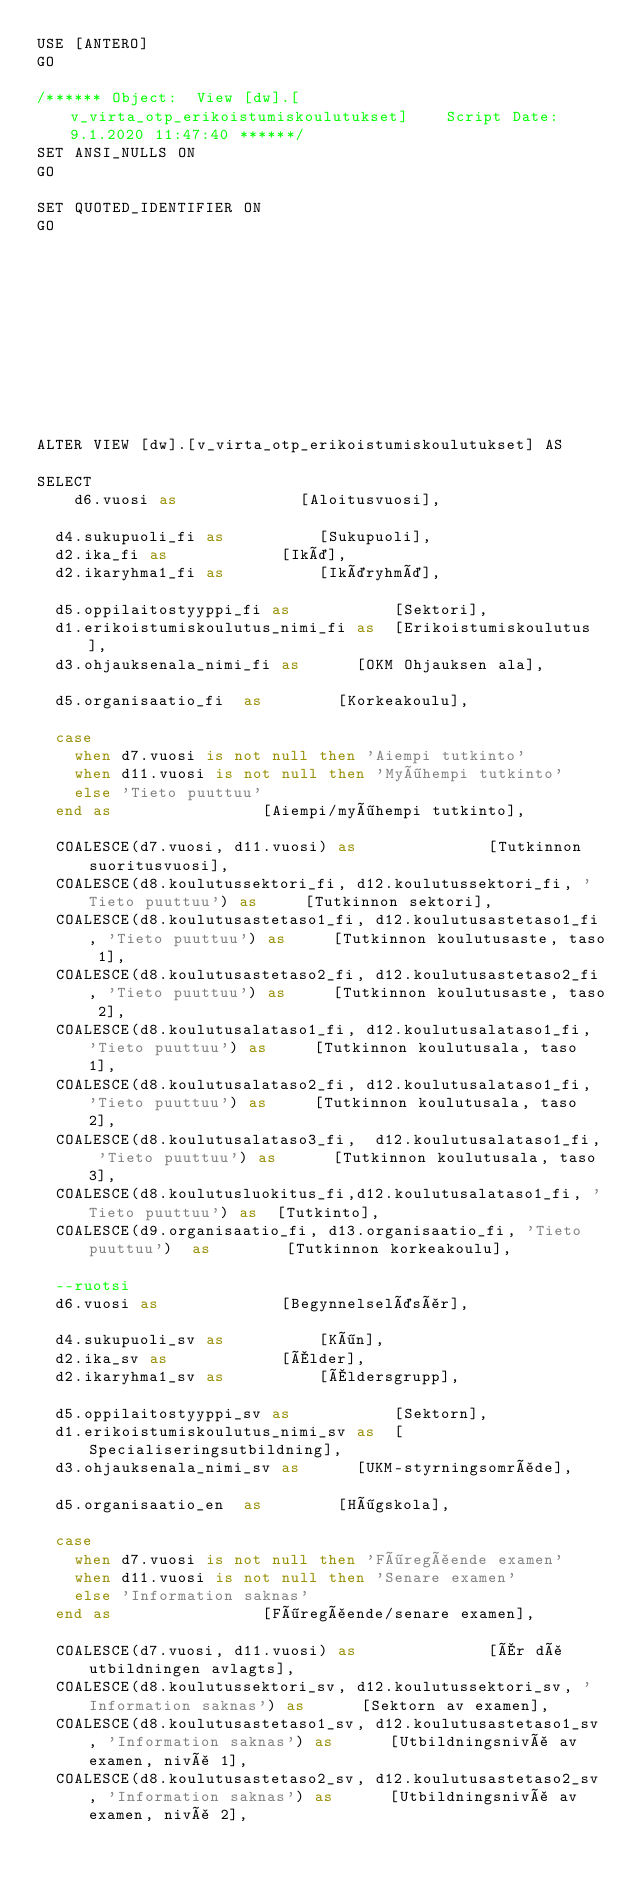<code> <loc_0><loc_0><loc_500><loc_500><_SQL_>USE [ANTERO]
GO

/****** Object:  View [dw].[v_virta_otp_erikoistumiskoulutukset]    Script Date: 9.1.2020 11:47:40 ******/
SET ANSI_NULLS ON
GO

SET QUOTED_IDENTIFIER ON
GO











ALTER VIEW [dw].[v_virta_otp_erikoistumiskoulutukset] AS

SELECT   	
    d6.vuosi as							[Aloitusvuosi],

	d4.sukupuoli_fi	as					[Sukupuoli],
	d2.ika_fi	as						[Ikä],
	d2.ikaryhma1_fi	as					[Ikäryhmä],
	
	d5.oppilaitostyyppi_fi as           [Sektori],
	d1.erikoistumiskoulutus_nimi_fi as  [Erikoistumiskoulutus],
	d3.ohjauksenala_nimi_fi	as			[OKM Ohjauksen ala],

	d5.organisaatio_fi	as				[Korkeakoulu],

	case 
		when d7.vuosi is not null then 'Aiempi tutkinto'
		when d11.vuosi is not null then 'Myöhempi tutkinto'
		else 'Tieto puuttuu'
	end as								[Aiempi/myöhempi tutkinto],

	COALESCE(d7.vuosi, d11.vuosi) as							[Tutkinnon suoritusvuosi],
	COALESCE(d8.koulutussektori_fi, d12.koulutussektori_fi, 'Tieto puuttuu') as			[Tutkinnon sektori],
	COALESCE(d8.koulutusastetaso1_fi, d12.koulutusastetaso1_fi, 'Tieto puuttuu') as			[Tutkinnon koulutusaste, taso 1],
	COALESCE(d8.koulutusastetaso2_fi, d12.koulutusastetaso2_fi, 'Tieto puuttuu') as			[Tutkinnon koulutusaste, taso 2],
	COALESCE(d8.koulutusalataso1_fi, d12.koulutusalataso1_fi, 'Tieto puuttuu') as			[Tutkinnon koulutusala, taso 1],
	COALESCE(d8.koulutusalataso2_fi, d12.koulutusalataso1_fi, 'Tieto puuttuu') as			[Tutkinnon koulutusala, taso 2],
	COALESCE(d8.koulutusalataso3_fi,  d12.koulutusalataso1_fi, 'Tieto puuttuu') as			[Tutkinnon koulutusala, taso 3],
	COALESCE(d8.koulutusluokitus_fi,d12.koulutusalataso1_fi, 'Tieto puuttuu') as	[Tutkinto],
	COALESCE(d9.organisaatio_fi, d13.organisaatio_fi, 'Tieto puuttuu')	as				[Tutkinnon korkeakoulu],

	--ruotsi
	d6.vuosi as							[Begynnelseläsår],

	d4.sukupuoli_sv	as					[Kön],
	d2.ika_sv	as						[Ålder],
	d2.ikaryhma1_sv	as					[Åldersgrupp],
	
	d5.oppilaitostyyppi_sv as           [Sektorn],
	d1.erikoistumiskoulutus_nimi_sv as  [Specialiseringsutbildning],
	d3.ohjauksenala_nimi_sv	as			[UKM-styrningsområde],

	d5.organisaatio_en	as				[Högskola],

	case 
		when d7.vuosi is not null then 'Föregående examen'
		when d11.vuosi is not null then 'Senare examen'
		else 'Information saknas'
	end as								[Föregående/senare examen],

	COALESCE(d7.vuosi, d11.vuosi) as							[År då utbildningen avlagts],
	COALESCE(d8.koulutussektori_sv, d12.koulutussektori_sv, 'Information saknas') as			[Sektorn av examen],
	COALESCE(d8.koulutusastetaso1_sv, d12.koulutusastetaso1_sv, 'Information saknas') as			[Utbildningsnivå av examen, nivå 1],
	COALESCE(d8.koulutusastetaso2_sv, d12.koulutusastetaso2_sv, 'Information saknas') as			[Utbildningsnivå av examen, nivå 2],</code> 